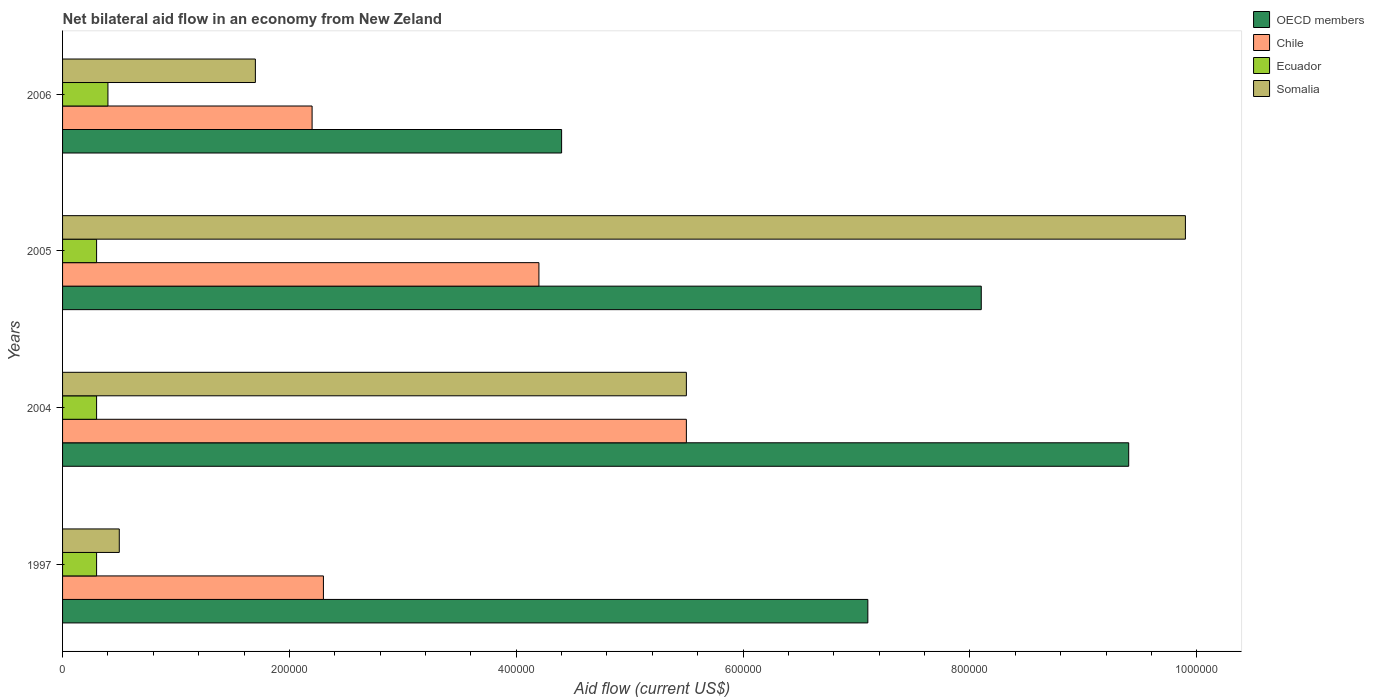How many different coloured bars are there?
Provide a succinct answer. 4. How many groups of bars are there?
Provide a short and direct response. 4. Are the number of bars on each tick of the Y-axis equal?
Your response must be concise. Yes. Across all years, what is the maximum net bilateral aid flow in OECD members?
Provide a short and direct response. 9.40e+05. In which year was the net bilateral aid flow in Chile maximum?
Your response must be concise. 2004. What is the total net bilateral aid flow in Chile in the graph?
Provide a short and direct response. 1.42e+06. What is the difference between the net bilateral aid flow in Chile in 1997 and that in 2004?
Offer a terse response. -3.20e+05. What is the difference between the net bilateral aid flow in Somalia in 2004 and the net bilateral aid flow in Ecuador in 2006?
Ensure brevity in your answer.  5.10e+05. What is the average net bilateral aid flow in Ecuador per year?
Your answer should be very brief. 3.25e+04. In how many years, is the net bilateral aid flow in Somalia greater than 160000 US$?
Offer a very short reply. 3. What is the ratio of the net bilateral aid flow in Chile in 2005 to that in 2006?
Provide a succinct answer. 1.91. In how many years, is the net bilateral aid flow in Somalia greater than the average net bilateral aid flow in Somalia taken over all years?
Provide a short and direct response. 2. Is the sum of the net bilateral aid flow in Ecuador in 2004 and 2005 greater than the maximum net bilateral aid flow in Chile across all years?
Your answer should be compact. No. Is it the case that in every year, the sum of the net bilateral aid flow in Somalia and net bilateral aid flow in Ecuador is greater than the sum of net bilateral aid flow in Chile and net bilateral aid flow in OECD members?
Provide a short and direct response. No. What does the 4th bar from the top in 2006 represents?
Provide a short and direct response. OECD members. What does the 3rd bar from the bottom in 2005 represents?
Give a very brief answer. Ecuador. Is it the case that in every year, the sum of the net bilateral aid flow in Ecuador and net bilateral aid flow in OECD members is greater than the net bilateral aid flow in Chile?
Your answer should be very brief. Yes. How many bars are there?
Provide a short and direct response. 16. Are all the bars in the graph horizontal?
Ensure brevity in your answer.  Yes. How many years are there in the graph?
Make the answer very short. 4. What is the difference between two consecutive major ticks on the X-axis?
Give a very brief answer. 2.00e+05. Are the values on the major ticks of X-axis written in scientific E-notation?
Give a very brief answer. No. Does the graph contain any zero values?
Offer a very short reply. No. Does the graph contain grids?
Provide a short and direct response. No. Where does the legend appear in the graph?
Provide a short and direct response. Top right. How many legend labels are there?
Offer a terse response. 4. How are the legend labels stacked?
Your answer should be very brief. Vertical. What is the title of the graph?
Keep it short and to the point. Net bilateral aid flow in an economy from New Zeland. Does "Kyrgyz Republic" appear as one of the legend labels in the graph?
Give a very brief answer. No. What is the label or title of the X-axis?
Your answer should be very brief. Aid flow (current US$). What is the Aid flow (current US$) of OECD members in 1997?
Provide a short and direct response. 7.10e+05. What is the Aid flow (current US$) in Ecuador in 1997?
Ensure brevity in your answer.  3.00e+04. What is the Aid flow (current US$) of OECD members in 2004?
Keep it short and to the point. 9.40e+05. What is the Aid flow (current US$) of Chile in 2004?
Keep it short and to the point. 5.50e+05. What is the Aid flow (current US$) of OECD members in 2005?
Keep it short and to the point. 8.10e+05. What is the Aid flow (current US$) in Ecuador in 2005?
Your response must be concise. 3.00e+04. What is the Aid flow (current US$) in Somalia in 2005?
Provide a succinct answer. 9.90e+05. What is the Aid flow (current US$) of Chile in 2006?
Give a very brief answer. 2.20e+05. What is the Aid flow (current US$) in Ecuador in 2006?
Your response must be concise. 4.00e+04. What is the Aid flow (current US$) of Somalia in 2006?
Ensure brevity in your answer.  1.70e+05. Across all years, what is the maximum Aid flow (current US$) of OECD members?
Offer a terse response. 9.40e+05. Across all years, what is the maximum Aid flow (current US$) of Ecuador?
Give a very brief answer. 4.00e+04. Across all years, what is the maximum Aid flow (current US$) of Somalia?
Give a very brief answer. 9.90e+05. Across all years, what is the minimum Aid flow (current US$) of OECD members?
Provide a short and direct response. 4.40e+05. Across all years, what is the minimum Aid flow (current US$) of Ecuador?
Provide a succinct answer. 3.00e+04. Across all years, what is the minimum Aid flow (current US$) of Somalia?
Offer a terse response. 5.00e+04. What is the total Aid flow (current US$) of OECD members in the graph?
Your answer should be compact. 2.90e+06. What is the total Aid flow (current US$) in Chile in the graph?
Make the answer very short. 1.42e+06. What is the total Aid flow (current US$) in Ecuador in the graph?
Provide a succinct answer. 1.30e+05. What is the total Aid flow (current US$) of Somalia in the graph?
Ensure brevity in your answer.  1.76e+06. What is the difference between the Aid flow (current US$) of Chile in 1997 and that in 2004?
Your response must be concise. -3.20e+05. What is the difference between the Aid flow (current US$) of Somalia in 1997 and that in 2004?
Make the answer very short. -5.00e+05. What is the difference between the Aid flow (current US$) of OECD members in 1997 and that in 2005?
Your answer should be very brief. -1.00e+05. What is the difference between the Aid flow (current US$) of Somalia in 1997 and that in 2005?
Ensure brevity in your answer.  -9.40e+05. What is the difference between the Aid flow (current US$) in Chile in 1997 and that in 2006?
Keep it short and to the point. 10000. What is the difference between the Aid flow (current US$) in Ecuador in 1997 and that in 2006?
Give a very brief answer. -10000. What is the difference between the Aid flow (current US$) of Somalia in 1997 and that in 2006?
Offer a very short reply. -1.20e+05. What is the difference between the Aid flow (current US$) of Chile in 2004 and that in 2005?
Your answer should be very brief. 1.30e+05. What is the difference between the Aid flow (current US$) in Ecuador in 2004 and that in 2005?
Give a very brief answer. 0. What is the difference between the Aid flow (current US$) in Somalia in 2004 and that in 2005?
Give a very brief answer. -4.40e+05. What is the difference between the Aid flow (current US$) of OECD members in 2004 and that in 2006?
Provide a short and direct response. 5.00e+05. What is the difference between the Aid flow (current US$) in Somalia in 2004 and that in 2006?
Offer a very short reply. 3.80e+05. What is the difference between the Aid flow (current US$) of Chile in 2005 and that in 2006?
Give a very brief answer. 2.00e+05. What is the difference between the Aid flow (current US$) of Ecuador in 2005 and that in 2006?
Offer a terse response. -10000. What is the difference between the Aid flow (current US$) of Somalia in 2005 and that in 2006?
Make the answer very short. 8.20e+05. What is the difference between the Aid flow (current US$) in OECD members in 1997 and the Aid flow (current US$) in Chile in 2004?
Ensure brevity in your answer.  1.60e+05. What is the difference between the Aid flow (current US$) of OECD members in 1997 and the Aid flow (current US$) of Ecuador in 2004?
Your answer should be very brief. 6.80e+05. What is the difference between the Aid flow (current US$) of Chile in 1997 and the Aid flow (current US$) of Ecuador in 2004?
Your response must be concise. 2.00e+05. What is the difference between the Aid flow (current US$) in Chile in 1997 and the Aid flow (current US$) in Somalia in 2004?
Ensure brevity in your answer.  -3.20e+05. What is the difference between the Aid flow (current US$) in Ecuador in 1997 and the Aid flow (current US$) in Somalia in 2004?
Keep it short and to the point. -5.20e+05. What is the difference between the Aid flow (current US$) in OECD members in 1997 and the Aid flow (current US$) in Ecuador in 2005?
Offer a very short reply. 6.80e+05. What is the difference between the Aid flow (current US$) in OECD members in 1997 and the Aid flow (current US$) in Somalia in 2005?
Provide a short and direct response. -2.80e+05. What is the difference between the Aid flow (current US$) in Chile in 1997 and the Aid flow (current US$) in Ecuador in 2005?
Provide a succinct answer. 2.00e+05. What is the difference between the Aid flow (current US$) in Chile in 1997 and the Aid flow (current US$) in Somalia in 2005?
Your response must be concise. -7.60e+05. What is the difference between the Aid flow (current US$) in Ecuador in 1997 and the Aid flow (current US$) in Somalia in 2005?
Provide a succinct answer. -9.60e+05. What is the difference between the Aid flow (current US$) of OECD members in 1997 and the Aid flow (current US$) of Chile in 2006?
Offer a very short reply. 4.90e+05. What is the difference between the Aid flow (current US$) in OECD members in 1997 and the Aid flow (current US$) in Ecuador in 2006?
Ensure brevity in your answer.  6.70e+05. What is the difference between the Aid flow (current US$) in OECD members in 1997 and the Aid flow (current US$) in Somalia in 2006?
Offer a very short reply. 5.40e+05. What is the difference between the Aid flow (current US$) in OECD members in 2004 and the Aid flow (current US$) in Chile in 2005?
Give a very brief answer. 5.20e+05. What is the difference between the Aid flow (current US$) of OECD members in 2004 and the Aid flow (current US$) of Ecuador in 2005?
Offer a very short reply. 9.10e+05. What is the difference between the Aid flow (current US$) of Chile in 2004 and the Aid flow (current US$) of Ecuador in 2005?
Make the answer very short. 5.20e+05. What is the difference between the Aid flow (current US$) of Chile in 2004 and the Aid flow (current US$) of Somalia in 2005?
Offer a very short reply. -4.40e+05. What is the difference between the Aid flow (current US$) of Ecuador in 2004 and the Aid flow (current US$) of Somalia in 2005?
Your response must be concise. -9.60e+05. What is the difference between the Aid flow (current US$) of OECD members in 2004 and the Aid flow (current US$) of Chile in 2006?
Your response must be concise. 7.20e+05. What is the difference between the Aid flow (current US$) of OECD members in 2004 and the Aid flow (current US$) of Ecuador in 2006?
Offer a terse response. 9.00e+05. What is the difference between the Aid flow (current US$) in OECD members in 2004 and the Aid flow (current US$) in Somalia in 2006?
Give a very brief answer. 7.70e+05. What is the difference between the Aid flow (current US$) in Chile in 2004 and the Aid flow (current US$) in Ecuador in 2006?
Provide a succinct answer. 5.10e+05. What is the difference between the Aid flow (current US$) of Chile in 2004 and the Aid flow (current US$) of Somalia in 2006?
Make the answer very short. 3.80e+05. What is the difference between the Aid flow (current US$) in Ecuador in 2004 and the Aid flow (current US$) in Somalia in 2006?
Provide a succinct answer. -1.40e+05. What is the difference between the Aid flow (current US$) in OECD members in 2005 and the Aid flow (current US$) in Chile in 2006?
Offer a very short reply. 5.90e+05. What is the difference between the Aid flow (current US$) in OECD members in 2005 and the Aid flow (current US$) in Ecuador in 2006?
Keep it short and to the point. 7.70e+05. What is the difference between the Aid flow (current US$) of OECD members in 2005 and the Aid flow (current US$) of Somalia in 2006?
Provide a succinct answer. 6.40e+05. What is the difference between the Aid flow (current US$) of Chile in 2005 and the Aid flow (current US$) of Ecuador in 2006?
Offer a very short reply. 3.80e+05. What is the difference between the Aid flow (current US$) of Chile in 2005 and the Aid flow (current US$) of Somalia in 2006?
Give a very brief answer. 2.50e+05. What is the difference between the Aid flow (current US$) in Ecuador in 2005 and the Aid flow (current US$) in Somalia in 2006?
Your answer should be compact. -1.40e+05. What is the average Aid flow (current US$) of OECD members per year?
Provide a short and direct response. 7.25e+05. What is the average Aid flow (current US$) in Chile per year?
Make the answer very short. 3.55e+05. What is the average Aid flow (current US$) in Ecuador per year?
Keep it short and to the point. 3.25e+04. In the year 1997, what is the difference between the Aid flow (current US$) of OECD members and Aid flow (current US$) of Chile?
Provide a short and direct response. 4.80e+05. In the year 1997, what is the difference between the Aid flow (current US$) in OECD members and Aid flow (current US$) in Ecuador?
Offer a very short reply. 6.80e+05. In the year 1997, what is the difference between the Aid flow (current US$) in Chile and Aid flow (current US$) in Ecuador?
Offer a terse response. 2.00e+05. In the year 2004, what is the difference between the Aid flow (current US$) of OECD members and Aid flow (current US$) of Chile?
Offer a terse response. 3.90e+05. In the year 2004, what is the difference between the Aid flow (current US$) of OECD members and Aid flow (current US$) of Ecuador?
Ensure brevity in your answer.  9.10e+05. In the year 2004, what is the difference between the Aid flow (current US$) in OECD members and Aid flow (current US$) in Somalia?
Offer a very short reply. 3.90e+05. In the year 2004, what is the difference between the Aid flow (current US$) in Chile and Aid flow (current US$) in Ecuador?
Provide a succinct answer. 5.20e+05. In the year 2004, what is the difference between the Aid flow (current US$) in Chile and Aid flow (current US$) in Somalia?
Provide a short and direct response. 0. In the year 2004, what is the difference between the Aid flow (current US$) in Ecuador and Aid flow (current US$) in Somalia?
Offer a terse response. -5.20e+05. In the year 2005, what is the difference between the Aid flow (current US$) of OECD members and Aid flow (current US$) of Chile?
Provide a short and direct response. 3.90e+05. In the year 2005, what is the difference between the Aid flow (current US$) in OECD members and Aid flow (current US$) in Ecuador?
Offer a very short reply. 7.80e+05. In the year 2005, what is the difference between the Aid flow (current US$) of Chile and Aid flow (current US$) of Somalia?
Provide a succinct answer. -5.70e+05. In the year 2005, what is the difference between the Aid flow (current US$) of Ecuador and Aid flow (current US$) of Somalia?
Ensure brevity in your answer.  -9.60e+05. In the year 2006, what is the difference between the Aid flow (current US$) of OECD members and Aid flow (current US$) of Chile?
Keep it short and to the point. 2.20e+05. In the year 2006, what is the difference between the Aid flow (current US$) of Chile and Aid flow (current US$) of Ecuador?
Ensure brevity in your answer.  1.80e+05. What is the ratio of the Aid flow (current US$) of OECD members in 1997 to that in 2004?
Provide a succinct answer. 0.76. What is the ratio of the Aid flow (current US$) of Chile in 1997 to that in 2004?
Give a very brief answer. 0.42. What is the ratio of the Aid flow (current US$) in Ecuador in 1997 to that in 2004?
Your response must be concise. 1. What is the ratio of the Aid flow (current US$) of Somalia in 1997 to that in 2004?
Your answer should be very brief. 0.09. What is the ratio of the Aid flow (current US$) in OECD members in 1997 to that in 2005?
Keep it short and to the point. 0.88. What is the ratio of the Aid flow (current US$) in Chile in 1997 to that in 2005?
Make the answer very short. 0.55. What is the ratio of the Aid flow (current US$) in Somalia in 1997 to that in 2005?
Your answer should be very brief. 0.05. What is the ratio of the Aid flow (current US$) of OECD members in 1997 to that in 2006?
Your response must be concise. 1.61. What is the ratio of the Aid flow (current US$) in Chile in 1997 to that in 2006?
Provide a short and direct response. 1.05. What is the ratio of the Aid flow (current US$) in Ecuador in 1997 to that in 2006?
Your response must be concise. 0.75. What is the ratio of the Aid flow (current US$) of Somalia in 1997 to that in 2006?
Provide a short and direct response. 0.29. What is the ratio of the Aid flow (current US$) of OECD members in 2004 to that in 2005?
Keep it short and to the point. 1.16. What is the ratio of the Aid flow (current US$) of Chile in 2004 to that in 2005?
Offer a very short reply. 1.31. What is the ratio of the Aid flow (current US$) of Somalia in 2004 to that in 2005?
Offer a terse response. 0.56. What is the ratio of the Aid flow (current US$) of OECD members in 2004 to that in 2006?
Your response must be concise. 2.14. What is the ratio of the Aid flow (current US$) of Chile in 2004 to that in 2006?
Keep it short and to the point. 2.5. What is the ratio of the Aid flow (current US$) of Ecuador in 2004 to that in 2006?
Your answer should be compact. 0.75. What is the ratio of the Aid flow (current US$) in Somalia in 2004 to that in 2006?
Your response must be concise. 3.24. What is the ratio of the Aid flow (current US$) in OECD members in 2005 to that in 2006?
Provide a short and direct response. 1.84. What is the ratio of the Aid flow (current US$) of Chile in 2005 to that in 2006?
Give a very brief answer. 1.91. What is the ratio of the Aid flow (current US$) of Ecuador in 2005 to that in 2006?
Ensure brevity in your answer.  0.75. What is the ratio of the Aid flow (current US$) in Somalia in 2005 to that in 2006?
Ensure brevity in your answer.  5.82. What is the difference between the highest and the second highest Aid flow (current US$) in Chile?
Your answer should be compact. 1.30e+05. What is the difference between the highest and the second highest Aid flow (current US$) of Ecuador?
Provide a short and direct response. 10000. What is the difference between the highest and the lowest Aid flow (current US$) in OECD members?
Give a very brief answer. 5.00e+05. What is the difference between the highest and the lowest Aid flow (current US$) of Somalia?
Provide a short and direct response. 9.40e+05. 